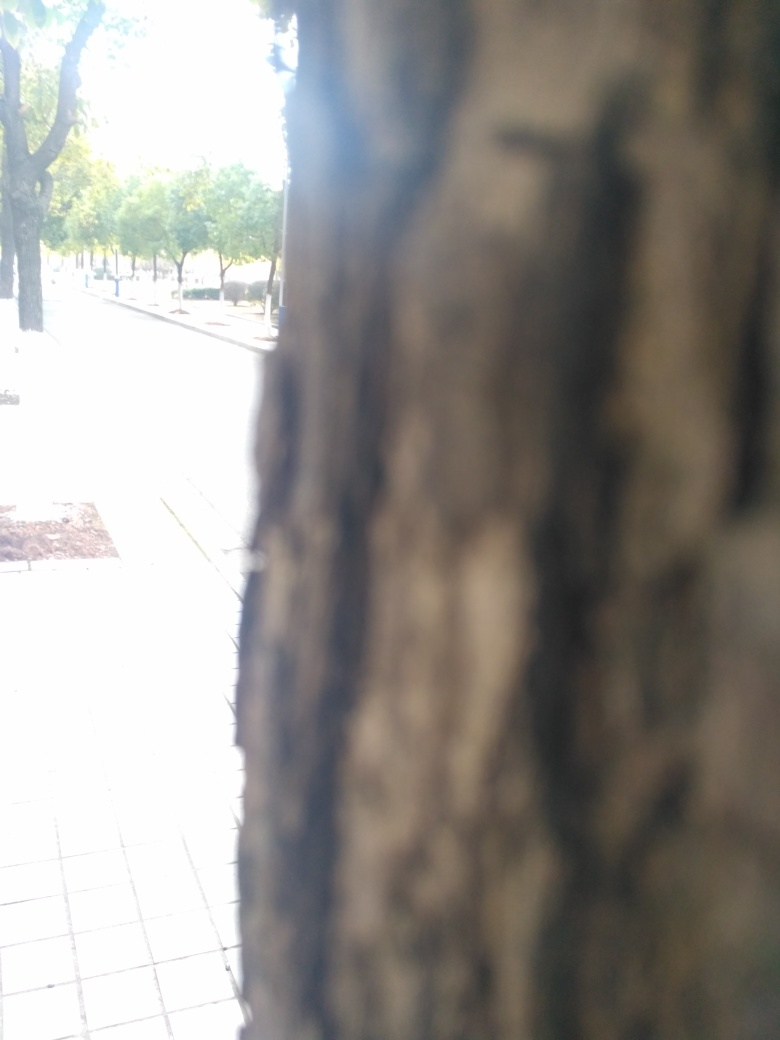How might the season affect the appearance of these trees? Depending on the season, the trees could vary significantly in appearance. During spring, they might display fresh, vibrant leaves, while in autumn, they could turn various shades of yellow, orange, and red before shedding their foliage, leaving bare branches in winter. Could this image have an artistic purpose? Yes, the selective focus technique employed in this image, emphasizing textural details of the bark while softening the backdrop, suggests an artistic intent. This approach draws the viewer's attention to the natural patterns of the tree's surface, fostering an appreciation for the intricate details often overlooked. 